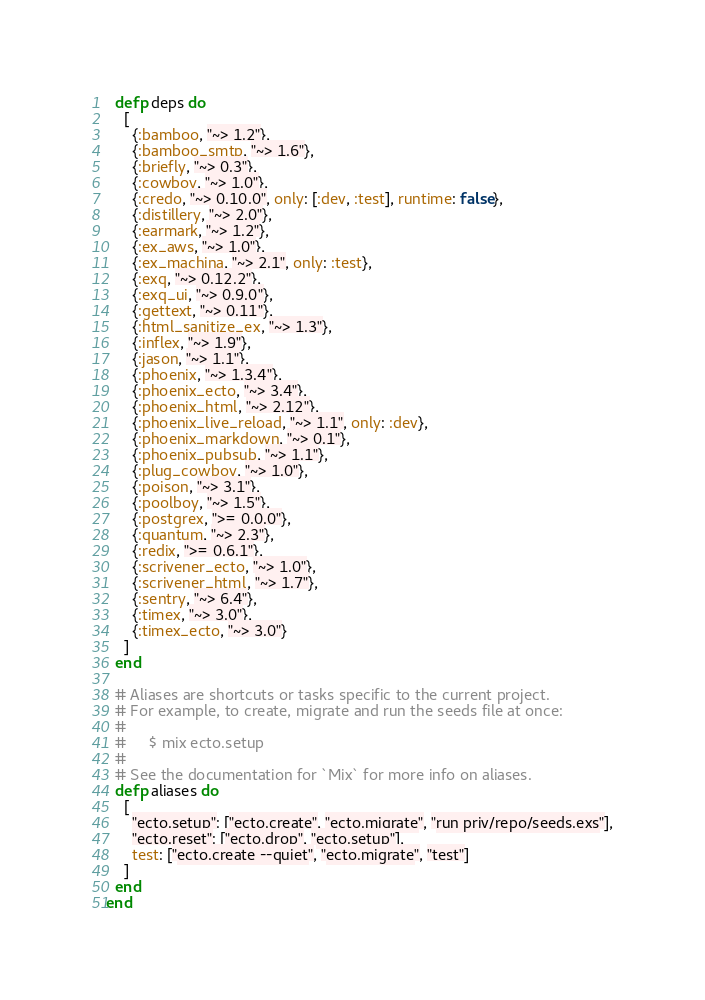Convert code to text. <code><loc_0><loc_0><loc_500><loc_500><_Elixir_>  defp deps do
    [
      {:bamboo, "~> 1.2"},
      {:bamboo_smtp, "~> 1.6"},
      {:briefly, "~> 0.3"},
      {:cowboy, "~> 1.0"},
      {:credo, "~> 0.10.0", only: [:dev, :test], runtime: false},
      {:distillery, "~> 2.0"},
      {:earmark, "~> 1.2"},
      {:ex_aws, "~> 1.0"},
      {:ex_machina, "~> 2.1", only: :test},
      {:exq, "~> 0.12.2"},
      {:exq_ui, "~> 0.9.0"},
      {:gettext, "~> 0.11"},
      {:html_sanitize_ex, "~> 1.3"},
      {:inflex, "~> 1.9"},
      {:jason, "~> 1.1"},
      {:phoenix, "~> 1.3.4"},
      {:phoenix_ecto, "~> 3.4"},
      {:phoenix_html, "~> 2.12"},
      {:phoenix_live_reload, "~> 1.1", only: :dev},
      {:phoenix_markdown, "~> 0.1"},
      {:phoenix_pubsub, "~> 1.1"},
      {:plug_cowboy, "~> 1.0"},
      {:poison, "~> 3.1"},
      {:poolboy, "~> 1.5"},
      {:postgrex, ">= 0.0.0"},
      {:quantum, "~> 2.3"},
      {:redix, ">= 0.6.1"},
      {:scrivener_ecto, "~> 1.0"},
      {:scrivener_html, "~> 1.7"},
      {:sentry, "~> 6.4"},
      {:timex, "~> 3.0"},
      {:timex_ecto, "~> 3.0"}
    ]
  end

  # Aliases are shortcuts or tasks specific to the current project.
  # For example, to create, migrate and run the seeds file at once:
  #
  #     $ mix ecto.setup
  #
  # See the documentation for `Mix` for more info on aliases.
  defp aliases do
    [
      "ecto.setup": ["ecto.create", "ecto.migrate", "run priv/repo/seeds.exs"],
      "ecto.reset": ["ecto.drop", "ecto.setup"],
      test: ["ecto.create --quiet", "ecto.migrate", "test"]
    ]
  end
end
</code> 